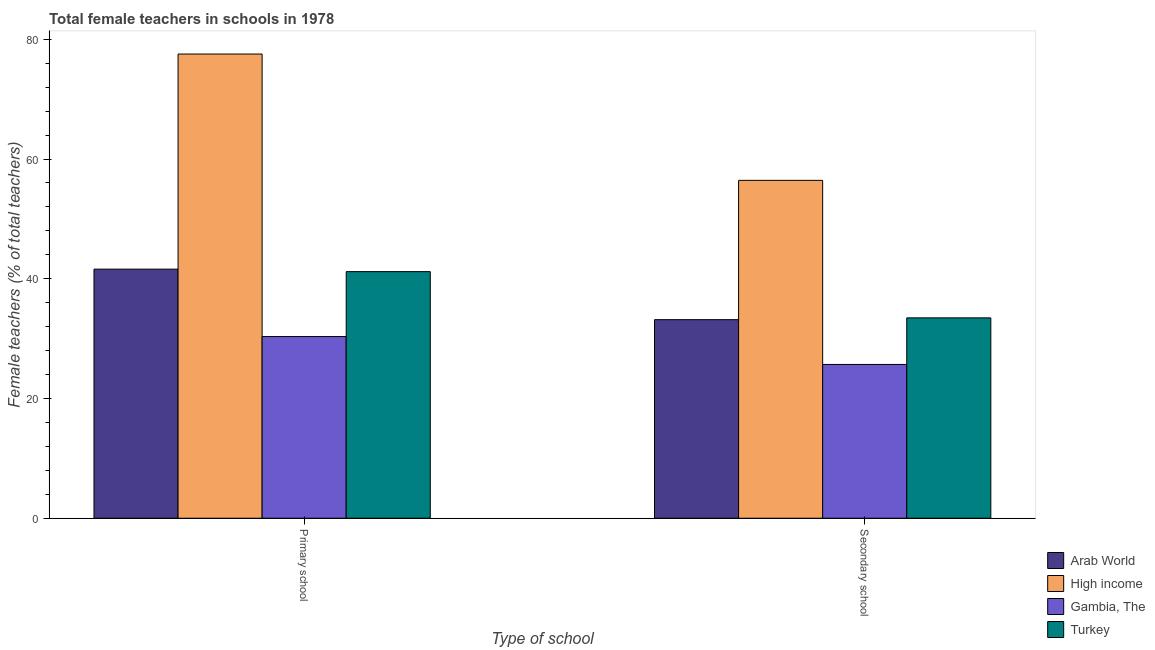Are the number of bars on each tick of the X-axis equal?
Provide a short and direct response. Yes. How many bars are there on the 1st tick from the left?
Provide a succinct answer. 4. What is the label of the 1st group of bars from the left?
Ensure brevity in your answer.  Primary school. What is the percentage of female teachers in secondary schools in Arab World?
Provide a short and direct response. 33.17. Across all countries, what is the maximum percentage of female teachers in primary schools?
Keep it short and to the point. 77.54. Across all countries, what is the minimum percentage of female teachers in secondary schools?
Your response must be concise. 25.69. In which country was the percentage of female teachers in secondary schools minimum?
Your response must be concise. Gambia, The. What is the total percentage of female teachers in secondary schools in the graph?
Ensure brevity in your answer.  148.77. What is the difference between the percentage of female teachers in primary schools in Arab World and that in Gambia, The?
Provide a short and direct response. 11.26. What is the difference between the percentage of female teachers in secondary schools in High income and the percentage of female teachers in primary schools in Arab World?
Ensure brevity in your answer.  14.83. What is the average percentage of female teachers in primary schools per country?
Ensure brevity in your answer.  47.67. What is the difference between the percentage of female teachers in secondary schools and percentage of female teachers in primary schools in Arab World?
Offer a terse response. -8.44. What is the ratio of the percentage of female teachers in primary schools in Turkey to that in Gambia, The?
Your answer should be compact. 1.36. Is the percentage of female teachers in primary schools in Arab World less than that in High income?
Provide a short and direct response. Yes. In how many countries, is the percentage of female teachers in primary schools greater than the average percentage of female teachers in primary schools taken over all countries?
Your response must be concise. 1. What does the 1st bar from the left in Secondary school represents?
Keep it short and to the point. Arab World. What does the 4th bar from the right in Secondary school represents?
Provide a short and direct response. Arab World. How many bars are there?
Offer a very short reply. 8. Does the graph contain grids?
Provide a succinct answer. No. How many legend labels are there?
Make the answer very short. 4. What is the title of the graph?
Your answer should be very brief. Total female teachers in schools in 1978. Does "Swaziland" appear as one of the legend labels in the graph?
Offer a very short reply. No. What is the label or title of the X-axis?
Ensure brevity in your answer.  Type of school. What is the label or title of the Y-axis?
Provide a short and direct response. Female teachers (% of total teachers). What is the Female teachers (% of total teachers) in Arab World in Primary school?
Your response must be concise. 41.61. What is the Female teachers (% of total teachers) of High income in Primary school?
Make the answer very short. 77.54. What is the Female teachers (% of total teachers) of Gambia, The in Primary school?
Keep it short and to the point. 30.35. What is the Female teachers (% of total teachers) in Turkey in Primary school?
Provide a succinct answer. 41.19. What is the Female teachers (% of total teachers) in Arab World in Secondary school?
Offer a terse response. 33.17. What is the Female teachers (% of total teachers) of High income in Secondary school?
Ensure brevity in your answer.  56.44. What is the Female teachers (% of total teachers) of Gambia, The in Secondary school?
Give a very brief answer. 25.69. What is the Female teachers (% of total teachers) of Turkey in Secondary school?
Provide a succinct answer. 33.47. Across all Type of school, what is the maximum Female teachers (% of total teachers) of Arab World?
Offer a very short reply. 41.61. Across all Type of school, what is the maximum Female teachers (% of total teachers) in High income?
Give a very brief answer. 77.54. Across all Type of school, what is the maximum Female teachers (% of total teachers) in Gambia, The?
Your answer should be compact. 30.35. Across all Type of school, what is the maximum Female teachers (% of total teachers) of Turkey?
Your answer should be very brief. 41.19. Across all Type of school, what is the minimum Female teachers (% of total teachers) in Arab World?
Provide a short and direct response. 33.17. Across all Type of school, what is the minimum Female teachers (% of total teachers) in High income?
Provide a short and direct response. 56.44. Across all Type of school, what is the minimum Female teachers (% of total teachers) of Gambia, The?
Your answer should be very brief. 25.69. Across all Type of school, what is the minimum Female teachers (% of total teachers) of Turkey?
Your answer should be very brief. 33.47. What is the total Female teachers (% of total teachers) of Arab World in the graph?
Provide a short and direct response. 74.78. What is the total Female teachers (% of total teachers) of High income in the graph?
Provide a succinct answer. 133.98. What is the total Female teachers (% of total teachers) of Gambia, The in the graph?
Provide a short and direct response. 56.04. What is the total Female teachers (% of total teachers) in Turkey in the graph?
Ensure brevity in your answer.  74.66. What is the difference between the Female teachers (% of total teachers) in Arab World in Primary school and that in Secondary school?
Offer a terse response. 8.44. What is the difference between the Female teachers (% of total teachers) in High income in Primary school and that in Secondary school?
Your response must be concise. 21.1. What is the difference between the Female teachers (% of total teachers) in Gambia, The in Primary school and that in Secondary school?
Your answer should be very brief. 4.66. What is the difference between the Female teachers (% of total teachers) in Turkey in Primary school and that in Secondary school?
Make the answer very short. 7.72. What is the difference between the Female teachers (% of total teachers) of Arab World in Primary school and the Female teachers (% of total teachers) of High income in Secondary school?
Your answer should be compact. -14.83. What is the difference between the Female teachers (% of total teachers) of Arab World in Primary school and the Female teachers (% of total teachers) of Gambia, The in Secondary school?
Offer a very short reply. 15.92. What is the difference between the Female teachers (% of total teachers) in Arab World in Primary school and the Female teachers (% of total teachers) in Turkey in Secondary school?
Give a very brief answer. 8.14. What is the difference between the Female teachers (% of total teachers) in High income in Primary school and the Female teachers (% of total teachers) in Gambia, The in Secondary school?
Your response must be concise. 51.85. What is the difference between the Female teachers (% of total teachers) of High income in Primary school and the Female teachers (% of total teachers) of Turkey in Secondary school?
Offer a terse response. 44.07. What is the difference between the Female teachers (% of total teachers) in Gambia, The in Primary school and the Female teachers (% of total teachers) in Turkey in Secondary school?
Provide a short and direct response. -3.12. What is the average Female teachers (% of total teachers) in Arab World per Type of school?
Make the answer very short. 37.39. What is the average Female teachers (% of total teachers) of High income per Type of school?
Ensure brevity in your answer.  66.99. What is the average Female teachers (% of total teachers) in Gambia, The per Type of school?
Ensure brevity in your answer.  28.02. What is the average Female teachers (% of total teachers) in Turkey per Type of school?
Offer a very short reply. 37.33. What is the difference between the Female teachers (% of total teachers) in Arab World and Female teachers (% of total teachers) in High income in Primary school?
Provide a succinct answer. -35.93. What is the difference between the Female teachers (% of total teachers) in Arab World and Female teachers (% of total teachers) in Gambia, The in Primary school?
Your answer should be very brief. 11.26. What is the difference between the Female teachers (% of total teachers) of Arab World and Female teachers (% of total teachers) of Turkey in Primary school?
Your response must be concise. 0.41. What is the difference between the Female teachers (% of total teachers) of High income and Female teachers (% of total teachers) of Gambia, The in Primary school?
Make the answer very short. 47.19. What is the difference between the Female teachers (% of total teachers) of High income and Female teachers (% of total teachers) of Turkey in Primary school?
Provide a short and direct response. 36.35. What is the difference between the Female teachers (% of total teachers) in Gambia, The and Female teachers (% of total teachers) in Turkey in Primary school?
Your answer should be very brief. -10.85. What is the difference between the Female teachers (% of total teachers) of Arab World and Female teachers (% of total teachers) of High income in Secondary school?
Your response must be concise. -23.27. What is the difference between the Female teachers (% of total teachers) in Arab World and Female teachers (% of total teachers) in Gambia, The in Secondary school?
Your answer should be compact. 7.48. What is the difference between the Female teachers (% of total teachers) of Arab World and Female teachers (% of total teachers) of Turkey in Secondary school?
Make the answer very short. -0.3. What is the difference between the Female teachers (% of total teachers) in High income and Female teachers (% of total teachers) in Gambia, The in Secondary school?
Give a very brief answer. 30.75. What is the difference between the Female teachers (% of total teachers) in High income and Female teachers (% of total teachers) in Turkey in Secondary school?
Keep it short and to the point. 22.97. What is the difference between the Female teachers (% of total teachers) in Gambia, The and Female teachers (% of total teachers) in Turkey in Secondary school?
Provide a succinct answer. -7.78. What is the ratio of the Female teachers (% of total teachers) in Arab World in Primary school to that in Secondary school?
Your answer should be very brief. 1.25. What is the ratio of the Female teachers (% of total teachers) of High income in Primary school to that in Secondary school?
Make the answer very short. 1.37. What is the ratio of the Female teachers (% of total teachers) in Gambia, The in Primary school to that in Secondary school?
Give a very brief answer. 1.18. What is the ratio of the Female teachers (% of total teachers) of Turkey in Primary school to that in Secondary school?
Your answer should be compact. 1.23. What is the difference between the highest and the second highest Female teachers (% of total teachers) in Arab World?
Your answer should be very brief. 8.44. What is the difference between the highest and the second highest Female teachers (% of total teachers) of High income?
Offer a very short reply. 21.1. What is the difference between the highest and the second highest Female teachers (% of total teachers) of Gambia, The?
Offer a very short reply. 4.66. What is the difference between the highest and the second highest Female teachers (% of total teachers) in Turkey?
Give a very brief answer. 7.72. What is the difference between the highest and the lowest Female teachers (% of total teachers) in Arab World?
Provide a succinct answer. 8.44. What is the difference between the highest and the lowest Female teachers (% of total teachers) in High income?
Provide a short and direct response. 21.1. What is the difference between the highest and the lowest Female teachers (% of total teachers) of Gambia, The?
Your answer should be very brief. 4.66. What is the difference between the highest and the lowest Female teachers (% of total teachers) of Turkey?
Provide a short and direct response. 7.72. 